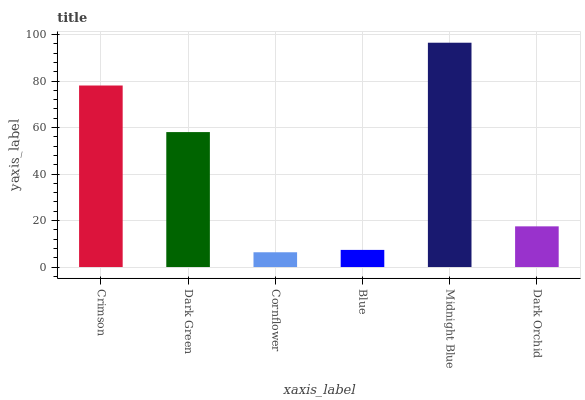Is Cornflower the minimum?
Answer yes or no. Yes. Is Midnight Blue the maximum?
Answer yes or no. Yes. Is Dark Green the minimum?
Answer yes or no. No. Is Dark Green the maximum?
Answer yes or no. No. Is Crimson greater than Dark Green?
Answer yes or no. Yes. Is Dark Green less than Crimson?
Answer yes or no. Yes. Is Dark Green greater than Crimson?
Answer yes or no. No. Is Crimson less than Dark Green?
Answer yes or no. No. Is Dark Green the high median?
Answer yes or no. Yes. Is Dark Orchid the low median?
Answer yes or no. Yes. Is Dark Orchid the high median?
Answer yes or no. No. Is Cornflower the low median?
Answer yes or no. No. 